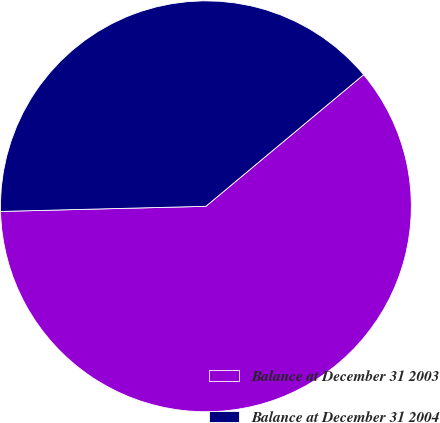<chart> <loc_0><loc_0><loc_500><loc_500><pie_chart><fcel>Balance at December 31 2003<fcel>Balance at December 31 2004<nl><fcel>60.67%<fcel>39.33%<nl></chart> 